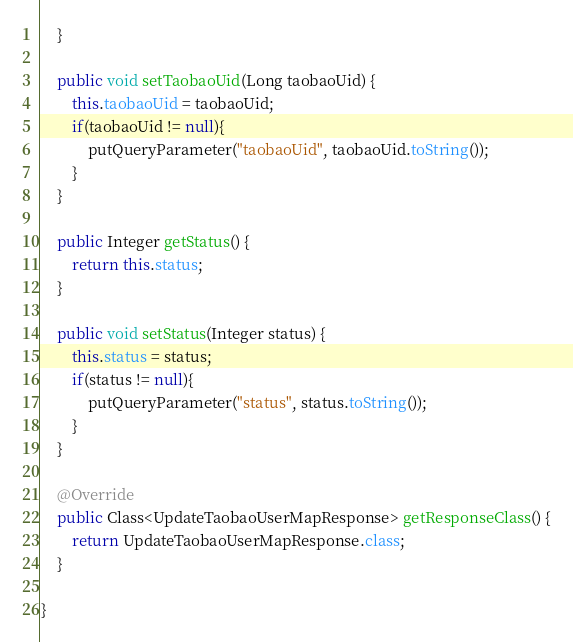<code> <loc_0><loc_0><loc_500><loc_500><_Java_>	}

	public void setTaobaoUid(Long taobaoUid) {
		this.taobaoUid = taobaoUid;
		if(taobaoUid != null){
			putQueryParameter("taobaoUid", taobaoUid.toString());
		}
	}

	public Integer getStatus() {
		return this.status;
	}

	public void setStatus(Integer status) {
		this.status = status;
		if(status != null){
			putQueryParameter("status", status.toString());
		}
	}

	@Override
	public Class<UpdateTaobaoUserMapResponse> getResponseClass() {
		return UpdateTaobaoUserMapResponse.class;
	}

}
</code> 